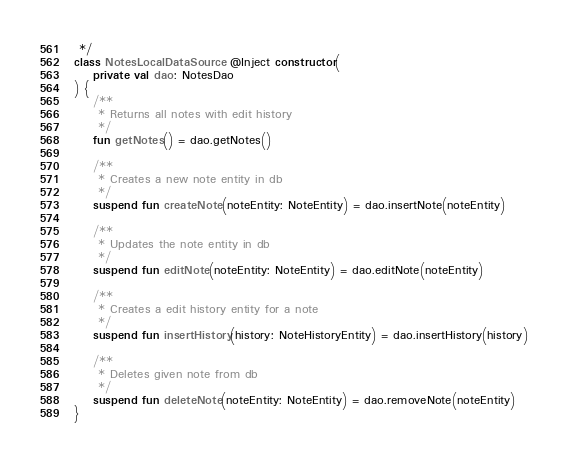Convert code to text. <code><loc_0><loc_0><loc_500><loc_500><_Kotlin_> */
class NotesLocalDataSource @Inject constructor(
    private val dao: NotesDao
) {
    /**
     * Returns all notes with edit history
     */
    fun getNotes() = dao.getNotes()

    /**
     * Creates a new note entity in db
     */
    suspend fun createNote(noteEntity: NoteEntity) = dao.insertNote(noteEntity)

    /**
     * Updates the note entity in db
     */
    suspend fun editNote(noteEntity: NoteEntity) = dao.editNote(noteEntity)

    /**
     * Creates a edit history entity for a note
     */
    suspend fun insertHistory(history: NoteHistoryEntity) = dao.insertHistory(history)

    /**
     * Deletes given note from db
     */
    suspend fun deleteNote(noteEntity: NoteEntity) = dao.removeNote(noteEntity)
}</code> 